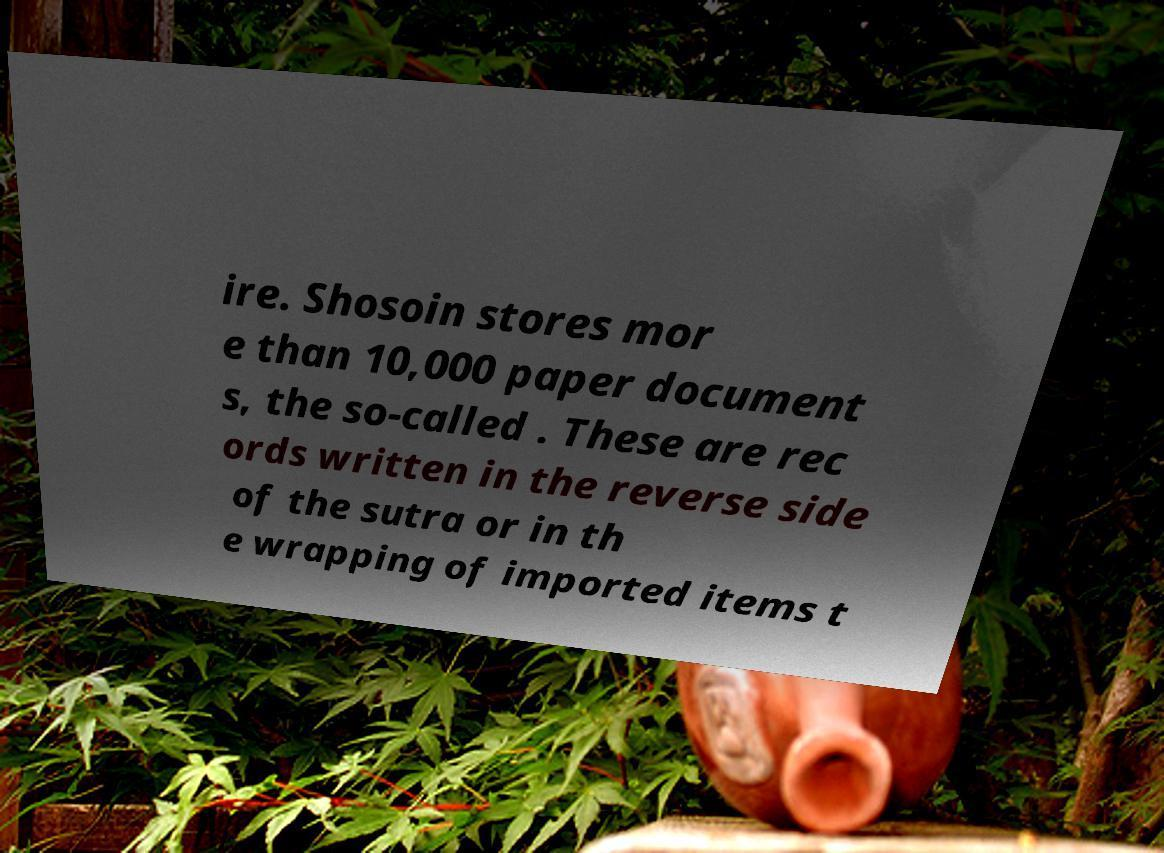I need the written content from this picture converted into text. Can you do that? ire. Shosoin stores mor e than 10,000 paper document s, the so-called . These are rec ords written in the reverse side of the sutra or in th e wrapping of imported items t 